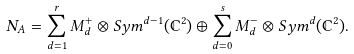<formula> <loc_0><loc_0><loc_500><loc_500>N _ { A } = \sum _ { d = 1 } ^ { r } M _ { d } ^ { + } \otimes S y m ^ { d - 1 } ( \mathbb { C } ^ { 2 } ) \oplus \sum _ { d = 0 } ^ { s } M _ { d } ^ { - } \otimes S y m ^ { d } ( \mathbb { C } ^ { 2 } ) .</formula> 